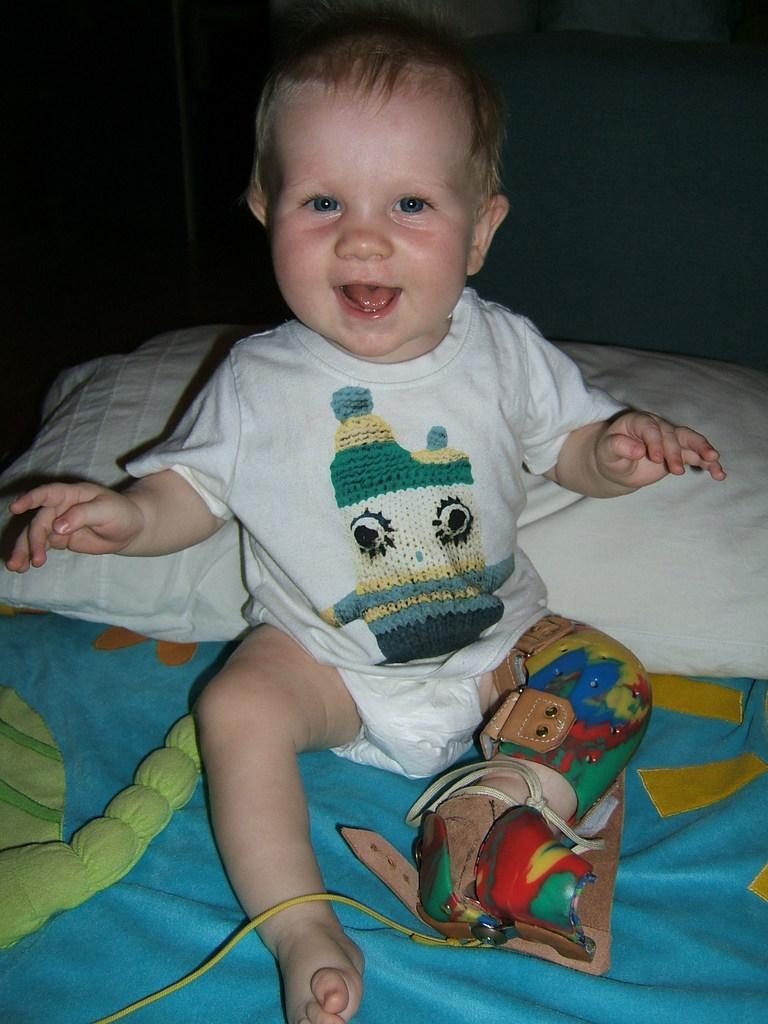What is the main subject of the image? The main subject of the image is a kid. What is the kid doing in the image? The kid is seated on a bed and smiling. What is located behind the kid? There is a pillow behind the kid. What type of letter is the cow holding in the image? There is no cow or letter present in the image; it features a kid seated on a bed with a pillow behind them. 